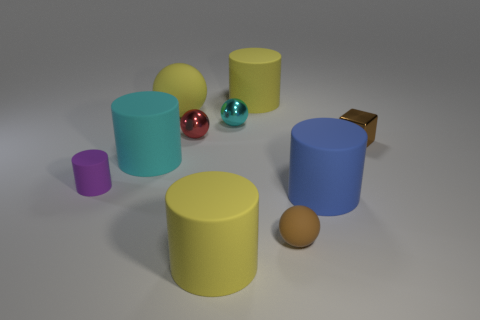Subtract 1 spheres. How many spheres are left? 3 Subtract all cyan matte cylinders. How many cylinders are left? 4 Subtract all green cylinders. Subtract all purple cubes. How many cylinders are left? 5 Subtract all balls. How many objects are left? 6 Subtract 1 red balls. How many objects are left? 9 Subtract all shiny things. Subtract all large gray rubber cylinders. How many objects are left? 7 Add 4 blue objects. How many blue objects are left? 5 Add 1 cyan shiny balls. How many cyan shiny balls exist? 2 